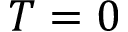Convert formula to latex. <formula><loc_0><loc_0><loc_500><loc_500>T = 0</formula> 